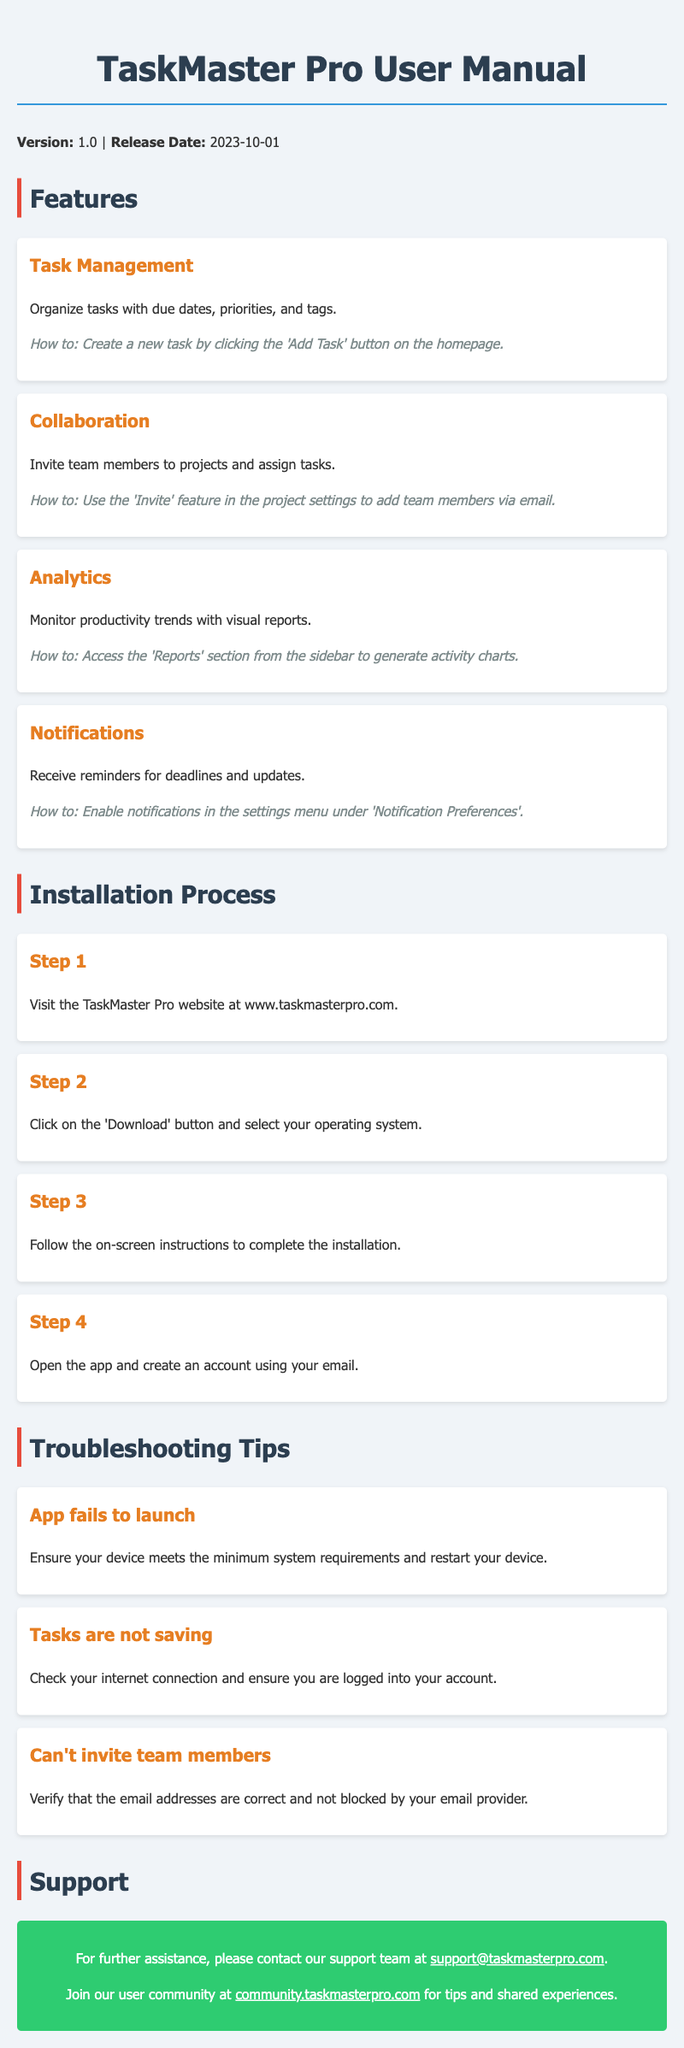What is the version of the app? The version is mentioned in the header of the document.
Answer: 1.0 What is the release date of TaskMaster Pro? The release date is stated alongside the version in the header.
Answer: 2023-10-01 What feature allows team members to be assigned tasks? The relevant feature is described in the features section.
Answer: Collaboration Where can the reports be accessed in the app? The location to access reports is specified in the Analytics feature.
Answer: Sidebar What step involves creating an account? The step related to account creation is listed in the installation process.
Answer: Step 4 What should you do if the app fails to launch? The troubleshooting tip suggests a specific action when the app fails to launch.
Answer: Restart your device What email should be contacted for support? The support contact email is provided in the support section.
Answer: support@taskmasterpro.com What should be checked if tasks are not saving? The troubleshooting tip outlines what to verify for this issue.
Answer: Internet connection 